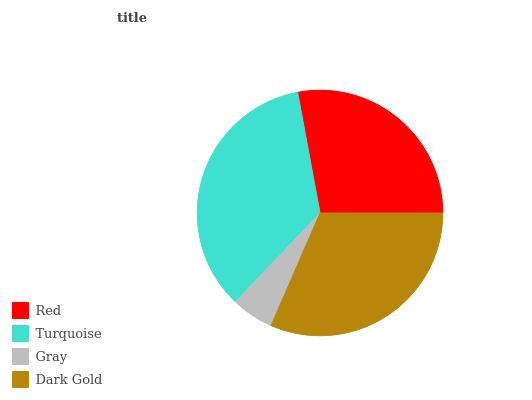Is Gray the minimum?
Answer yes or no. Yes. Is Turquoise the maximum?
Answer yes or no. Yes. Is Turquoise the minimum?
Answer yes or no. No. Is Gray the maximum?
Answer yes or no. No. Is Turquoise greater than Gray?
Answer yes or no. Yes. Is Gray less than Turquoise?
Answer yes or no. Yes. Is Gray greater than Turquoise?
Answer yes or no. No. Is Turquoise less than Gray?
Answer yes or no. No. Is Dark Gold the high median?
Answer yes or no. Yes. Is Red the low median?
Answer yes or no. Yes. Is Red the high median?
Answer yes or no. No. Is Dark Gold the low median?
Answer yes or no. No. 